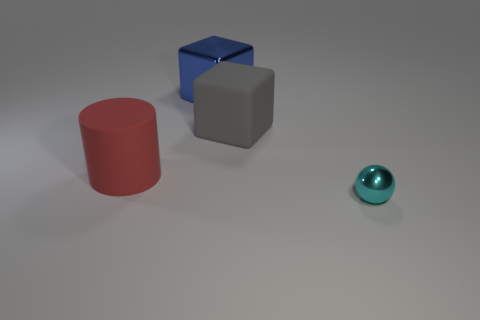Add 3 cyan matte spheres. How many objects exist? 7 Subtract all spheres. How many objects are left? 3 Add 4 large shiny objects. How many large shiny objects are left? 5 Add 3 green things. How many green things exist? 3 Subtract 1 blue blocks. How many objects are left? 3 Subtract all small cyan balls. Subtract all cyan balls. How many objects are left? 2 